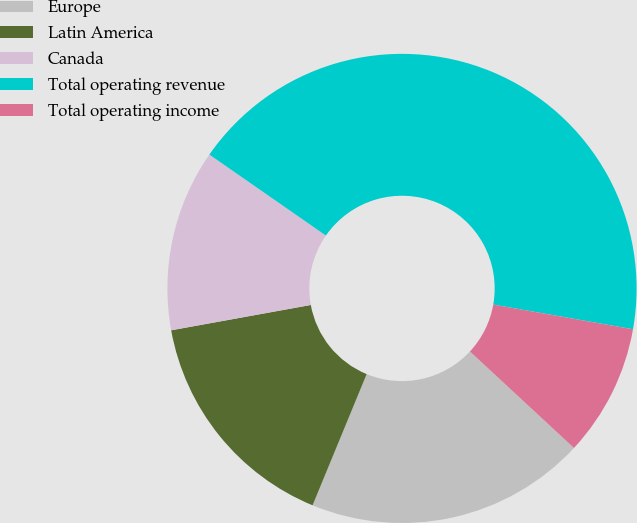<chart> <loc_0><loc_0><loc_500><loc_500><pie_chart><fcel>Europe<fcel>Latin America<fcel>Canada<fcel>Total operating revenue<fcel>Total operating income<nl><fcel>19.32%<fcel>15.92%<fcel>12.52%<fcel>43.12%<fcel>9.12%<nl></chart> 